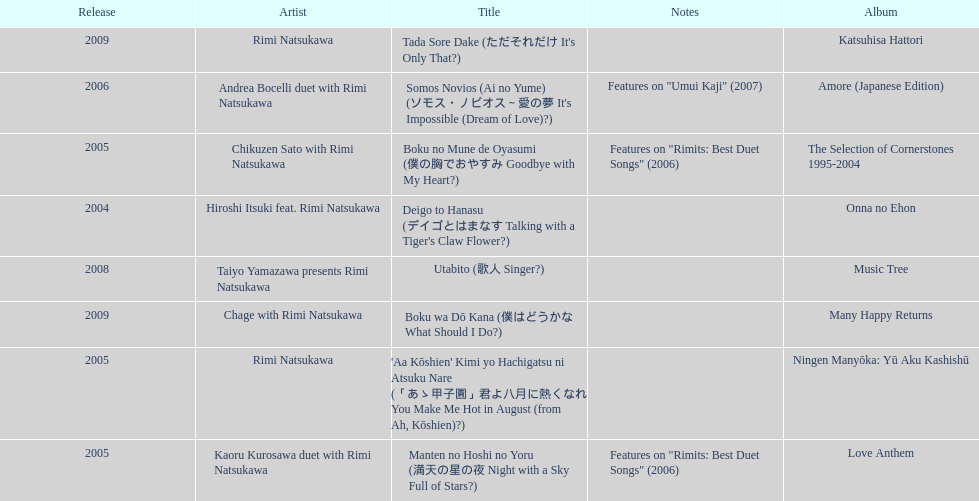How many titles have only one artist? 2. 